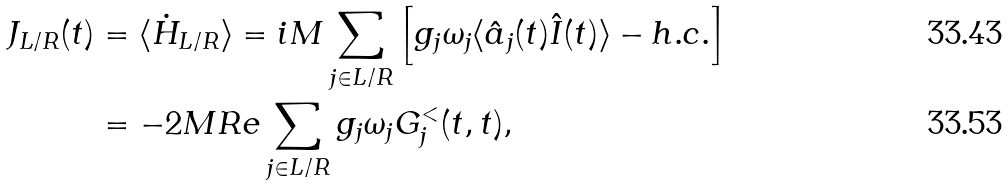Convert formula to latex. <formula><loc_0><loc_0><loc_500><loc_500>J _ { L / R } ( t ) & = \langle \dot { H } _ { L / R } \rangle = i M \sum _ { j \in L / R } \left [ g _ { j } \omega _ { j } \langle \hat { a } _ { j } ( t ) \hat { I } ( t ) \rangle - h . c . \right ] \\ & = - 2 M R e \sum _ { j \in L / R } g _ { j } \omega _ { j } G _ { j } ^ { < } ( t , t ) ,</formula> 